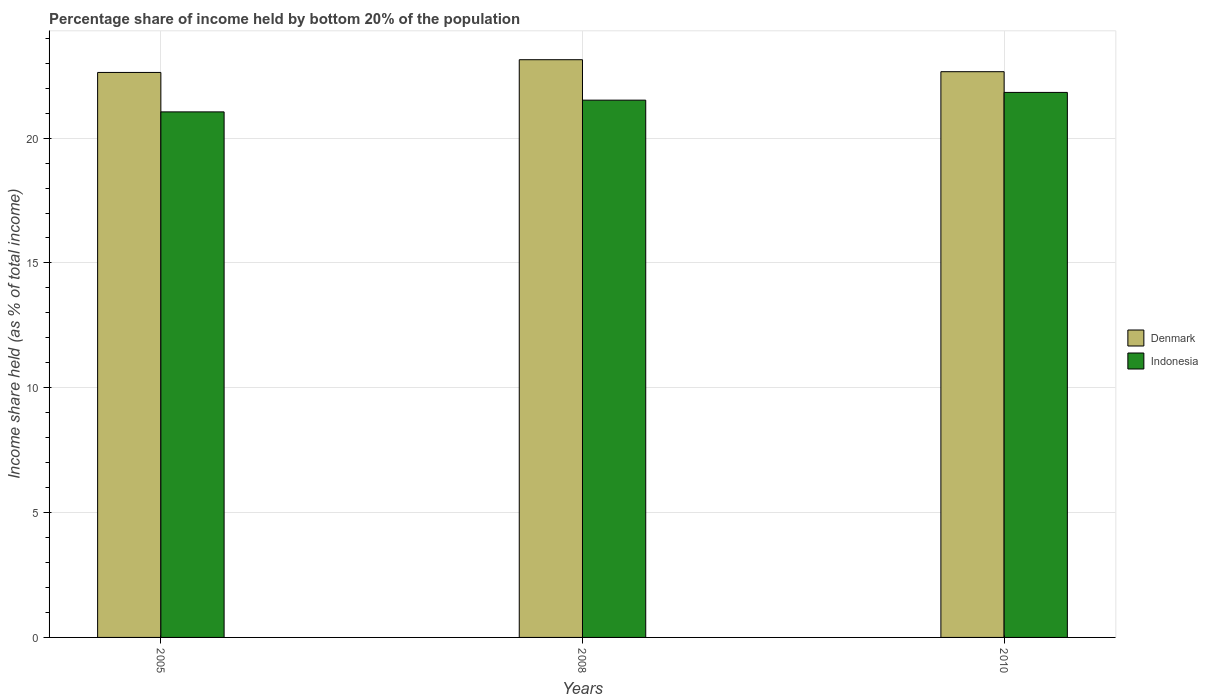How many different coloured bars are there?
Make the answer very short. 2. How many groups of bars are there?
Ensure brevity in your answer.  3. Are the number of bars on each tick of the X-axis equal?
Provide a succinct answer. Yes. How many bars are there on the 3rd tick from the left?
Ensure brevity in your answer.  2. How many bars are there on the 3rd tick from the right?
Make the answer very short. 2. What is the label of the 1st group of bars from the left?
Your response must be concise. 2005. What is the share of income held by bottom 20% of the population in Denmark in 2008?
Ensure brevity in your answer.  23.14. Across all years, what is the maximum share of income held by bottom 20% of the population in Indonesia?
Your answer should be very brief. 21.83. Across all years, what is the minimum share of income held by bottom 20% of the population in Denmark?
Provide a short and direct response. 22.63. In which year was the share of income held by bottom 20% of the population in Denmark maximum?
Your answer should be very brief. 2008. In which year was the share of income held by bottom 20% of the population in Denmark minimum?
Make the answer very short. 2005. What is the total share of income held by bottom 20% of the population in Denmark in the graph?
Provide a succinct answer. 68.43. What is the difference between the share of income held by bottom 20% of the population in Denmark in 2008 and that in 2010?
Provide a succinct answer. 0.48. What is the difference between the share of income held by bottom 20% of the population in Denmark in 2008 and the share of income held by bottom 20% of the population in Indonesia in 2010?
Offer a terse response. 1.31. What is the average share of income held by bottom 20% of the population in Indonesia per year?
Your response must be concise. 21.47. In the year 2005, what is the difference between the share of income held by bottom 20% of the population in Denmark and share of income held by bottom 20% of the population in Indonesia?
Keep it short and to the point. 1.58. In how many years, is the share of income held by bottom 20% of the population in Indonesia greater than 22 %?
Your response must be concise. 0. What is the ratio of the share of income held by bottom 20% of the population in Indonesia in 2008 to that in 2010?
Give a very brief answer. 0.99. Is the share of income held by bottom 20% of the population in Denmark in 2005 less than that in 2010?
Your answer should be compact. Yes. Is the difference between the share of income held by bottom 20% of the population in Denmark in 2005 and 2008 greater than the difference between the share of income held by bottom 20% of the population in Indonesia in 2005 and 2008?
Provide a succinct answer. No. What is the difference between the highest and the second highest share of income held by bottom 20% of the population in Denmark?
Make the answer very short. 0.48. What is the difference between the highest and the lowest share of income held by bottom 20% of the population in Indonesia?
Keep it short and to the point. 0.78. Is the sum of the share of income held by bottom 20% of the population in Indonesia in 2005 and 2008 greater than the maximum share of income held by bottom 20% of the population in Denmark across all years?
Offer a very short reply. Yes. What does the 2nd bar from the right in 2005 represents?
Provide a succinct answer. Denmark. How many bars are there?
Your answer should be compact. 6. Are all the bars in the graph horizontal?
Your answer should be compact. No. How many years are there in the graph?
Your answer should be compact. 3. What is the difference between two consecutive major ticks on the Y-axis?
Provide a succinct answer. 5. Are the values on the major ticks of Y-axis written in scientific E-notation?
Ensure brevity in your answer.  No. Does the graph contain any zero values?
Offer a very short reply. No. Where does the legend appear in the graph?
Offer a very short reply. Center right. What is the title of the graph?
Your answer should be very brief. Percentage share of income held by bottom 20% of the population. Does "Vanuatu" appear as one of the legend labels in the graph?
Give a very brief answer. No. What is the label or title of the X-axis?
Keep it short and to the point. Years. What is the label or title of the Y-axis?
Your answer should be very brief. Income share held (as % of total income). What is the Income share held (as % of total income) in Denmark in 2005?
Ensure brevity in your answer.  22.63. What is the Income share held (as % of total income) in Indonesia in 2005?
Ensure brevity in your answer.  21.05. What is the Income share held (as % of total income) in Denmark in 2008?
Make the answer very short. 23.14. What is the Income share held (as % of total income) in Indonesia in 2008?
Offer a terse response. 21.52. What is the Income share held (as % of total income) of Denmark in 2010?
Provide a succinct answer. 22.66. What is the Income share held (as % of total income) in Indonesia in 2010?
Provide a short and direct response. 21.83. Across all years, what is the maximum Income share held (as % of total income) in Denmark?
Offer a terse response. 23.14. Across all years, what is the maximum Income share held (as % of total income) in Indonesia?
Make the answer very short. 21.83. Across all years, what is the minimum Income share held (as % of total income) in Denmark?
Your answer should be very brief. 22.63. Across all years, what is the minimum Income share held (as % of total income) in Indonesia?
Give a very brief answer. 21.05. What is the total Income share held (as % of total income) of Denmark in the graph?
Provide a short and direct response. 68.43. What is the total Income share held (as % of total income) of Indonesia in the graph?
Your response must be concise. 64.4. What is the difference between the Income share held (as % of total income) of Denmark in 2005 and that in 2008?
Your answer should be very brief. -0.51. What is the difference between the Income share held (as % of total income) of Indonesia in 2005 and that in 2008?
Your answer should be compact. -0.47. What is the difference between the Income share held (as % of total income) of Denmark in 2005 and that in 2010?
Keep it short and to the point. -0.03. What is the difference between the Income share held (as % of total income) of Indonesia in 2005 and that in 2010?
Ensure brevity in your answer.  -0.78. What is the difference between the Income share held (as % of total income) in Denmark in 2008 and that in 2010?
Offer a very short reply. 0.48. What is the difference between the Income share held (as % of total income) of Indonesia in 2008 and that in 2010?
Ensure brevity in your answer.  -0.31. What is the difference between the Income share held (as % of total income) of Denmark in 2005 and the Income share held (as % of total income) of Indonesia in 2008?
Give a very brief answer. 1.11. What is the difference between the Income share held (as % of total income) in Denmark in 2005 and the Income share held (as % of total income) in Indonesia in 2010?
Your answer should be very brief. 0.8. What is the difference between the Income share held (as % of total income) in Denmark in 2008 and the Income share held (as % of total income) in Indonesia in 2010?
Offer a terse response. 1.31. What is the average Income share held (as % of total income) of Denmark per year?
Offer a terse response. 22.81. What is the average Income share held (as % of total income) of Indonesia per year?
Your answer should be very brief. 21.47. In the year 2005, what is the difference between the Income share held (as % of total income) of Denmark and Income share held (as % of total income) of Indonesia?
Your response must be concise. 1.58. In the year 2008, what is the difference between the Income share held (as % of total income) in Denmark and Income share held (as % of total income) in Indonesia?
Ensure brevity in your answer.  1.62. In the year 2010, what is the difference between the Income share held (as % of total income) in Denmark and Income share held (as % of total income) in Indonesia?
Your response must be concise. 0.83. What is the ratio of the Income share held (as % of total income) of Indonesia in 2005 to that in 2008?
Give a very brief answer. 0.98. What is the ratio of the Income share held (as % of total income) in Denmark in 2008 to that in 2010?
Make the answer very short. 1.02. What is the ratio of the Income share held (as % of total income) of Indonesia in 2008 to that in 2010?
Keep it short and to the point. 0.99. What is the difference between the highest and the second highest Income share held (as % of total income) in Denmark?
Give a very brief answer. 0.48. What is the difference between the highest and the second highest Income share held (as % of total income) in Indonesia?
Offer a terse response. 0.31. What is the difference between the highest and the lowest Income share held (as % of total income) in Denmark?
Offer a terse response. 0.51. What is the difference between the highest and the lowest Income share held (as % of total income) in Indonesia?
Keep it short and to the point. 0.78. 